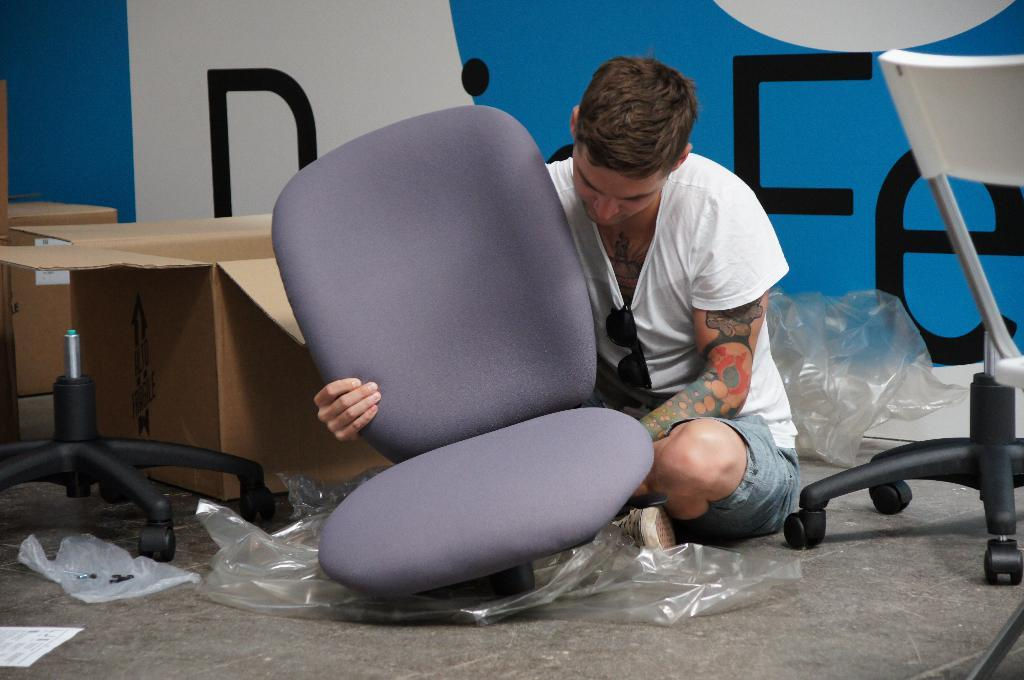What is the man in the image doing? The man is sitting on the floor and repairing a seat. Can you describe the man's appearance? The man is wearing spectacles. What can be seen in the background of the image? There is a box and a wall in the background. What color is the man's toe in the image? There is no mention of the man's toe in the provided facts, so we cannot determine its color. 